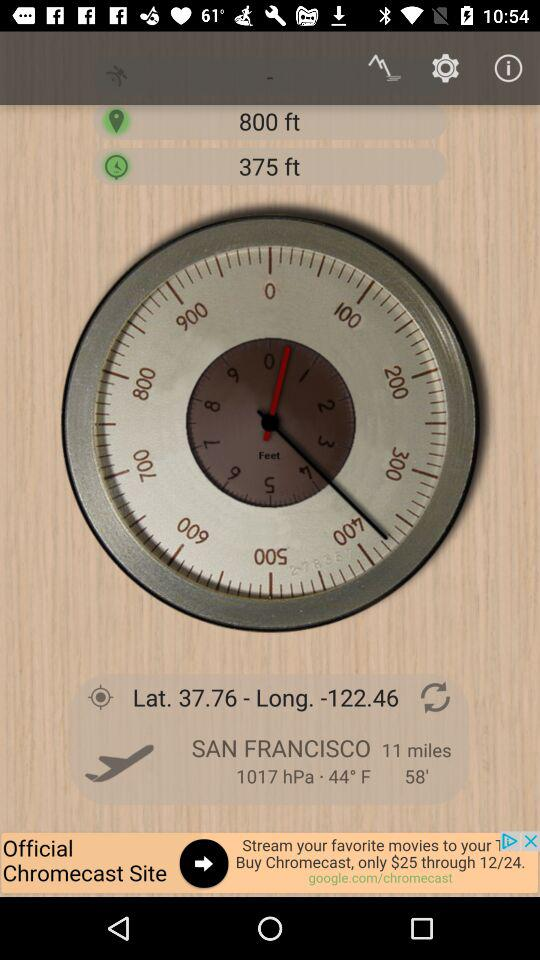What is the name of the application?
When the provided information is insufficient, respond with <no answer>. <no answer> 